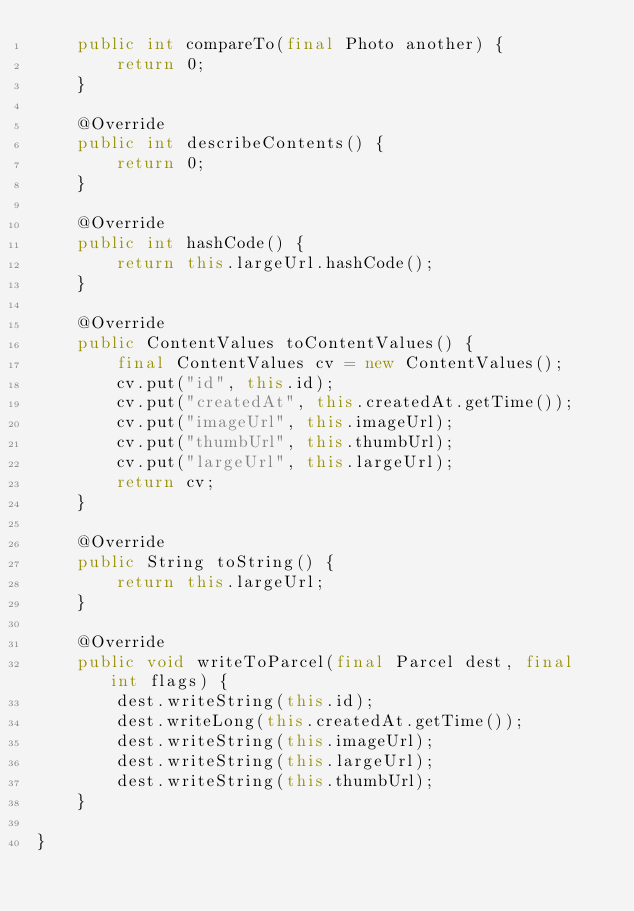<code> <loc_0><loc_0><loc_500><loc_500><_Java_>    public int compareTo(final Photo another) {
        return 0;
    }

    @Override
    public int describeContents() {
        return 0;
    }

    @Override
    public int hashCode() {
        return this.largeUrl.hashCode();
    }

    @Override
    public ContentValues toContentValues() {
        final ContentValues cv = new ContentValues();
        cv.put("id", this.id);
        cv.put("createdAt", this.createdAt.getTime());
        cv.put("imageUrl", this.imageUrl);
        cv.put("thumbUrl", this.thumbUrl);
        cv.put("largeUrl", this.largeUrl);
        return cv;
    }

    @Override
    public String toString() {
        return this.largeUrl;
    }

    @Override
    public void writeToParcel(final Parcel dest, final int flags) {
        dest.writeString(this.id);
        dest.writeLong(this.createdAt.getTime());
        dest.writeString(this.imageUrl);
        dest.writeString(this.largeUrl);
        dest.writeString(this.thumbUrl);
    }

}
</code> 